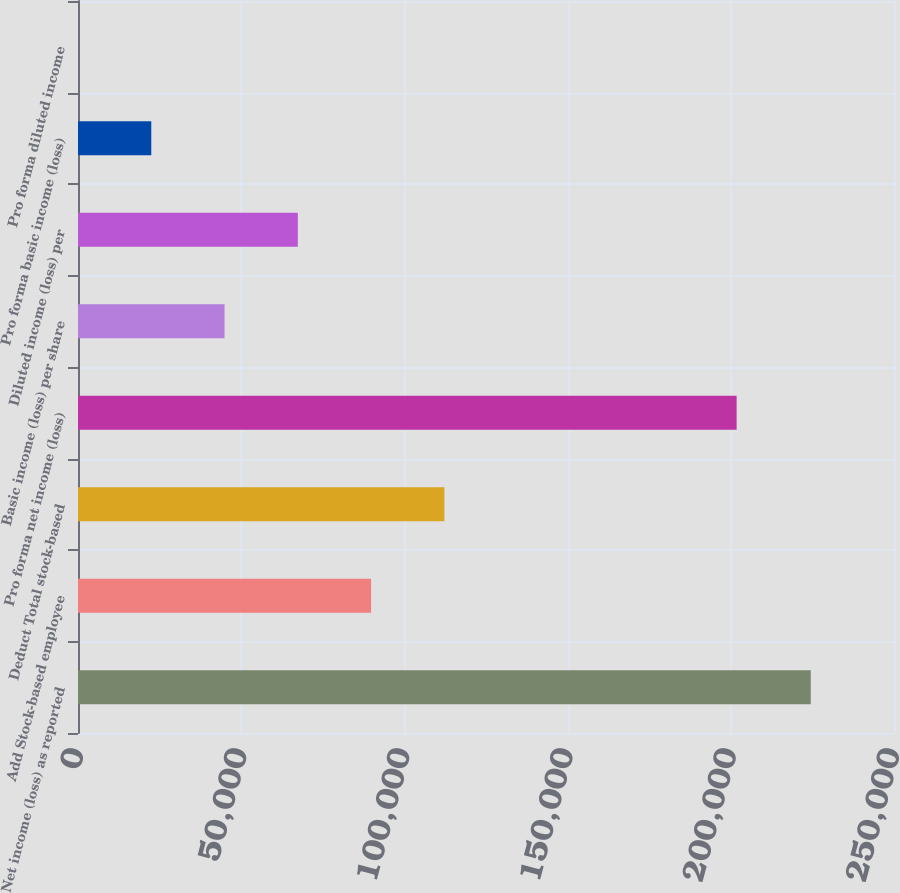Convert chart to OTSL. <chart><loc_0><loc_0><loc_500><loc_500><bar_chart><fcel>Net income (loss) as reported<fcel>Add Stock-based employee<fcel>Deduct Total stock-based<fcel>Pro forma net income (loss)<fcel>Basic income (loss) per share<fcel>Diluted income (loss) per<fcel>Pro forma basic income (loss)<fcel>Pro forma diluted income<nl><fcel>224506<fcel>89802.6<fcel>112253<fcel>201788<fcel>44901.5<fcel>67352.1<fcel>22451<fcel>0.41<nl></chart> 